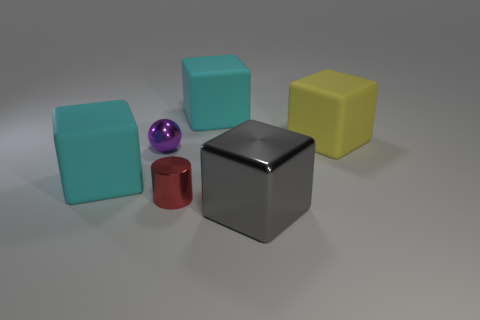Are there fewer big shiny things that are in front of the gray shiny cube than big yellow blocks?
Your answer should be very brief. Yes. There is a cyan matte thing right of the small purple metal sphere behind the cyan thing to the left of the red thing; what is its size?
Your response must be concise. Large. What is the color of the thing that is in front of the small sphere and left of the small metal cylinder?
Provide a short and direct response. Cyan. How many red rubber cylinders are there?
Ensure brevity in your answer.  0. Do the small red cylinder and the sphere have the same material?
Make the answer very short. Yes. Is the size of the yellow thing on the right side of the tiny sphere the same as the shiny object left of the tiny red object?
Offer a very short reply. No. Are there fewer green shiny cylinders than gray objects?
Your response must be concise. Yes. What number of metallic things are either cylinders or big cyan things?
Your response must be concise. 1. Is there a matte block in front of the tiny object that is left of the red cylinder?
Offer a very short reply. Yes. Do the big cyan block that is right of the metallic cylinder and the tiny purple thing have the same material?
Give a very brief answer. No. 